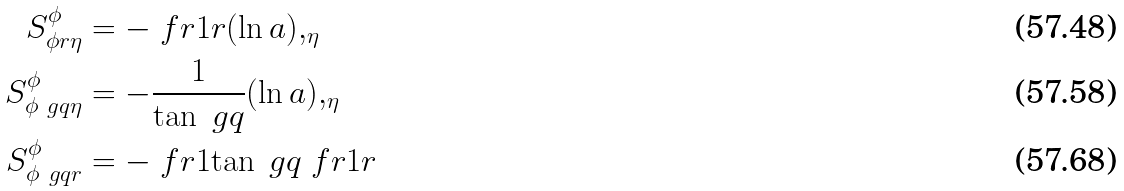<formula> <loc_0><loc_0><loc_500><loc_500>S _ { \phi r \eta } ^ { \phi } & = - \ f r { 1 } { r } ( \ln a ) , _ { \eta } \\ S _ { \phi \ g q \eta } ^ { \phi } & = - \frac { 1 } { \tan \ g q } ( \ln a ) , _ { \eta } \\ S _ { \phi \ g q r } ^ { \phi } & = - \ f r { 1 } { \tan \ g q } \ f r { 1 } { r }</formula> 